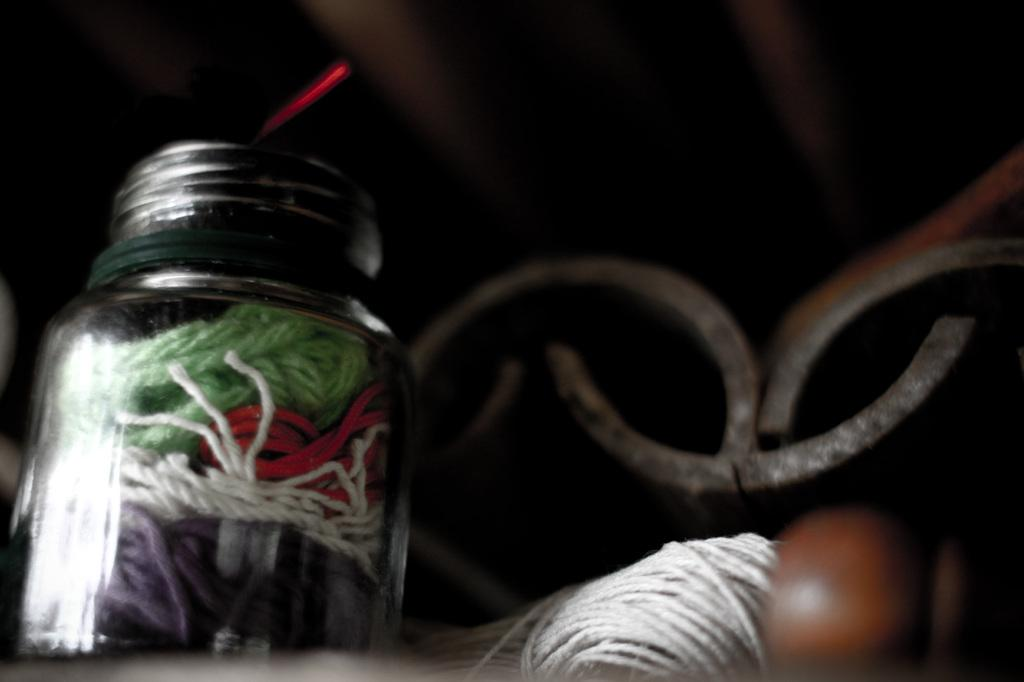What object is visible in the image that is made of glass? There is a glass bottle in the image. What is inside the glass bottle? Colorful threads are inside the bottle. What can be seen on the right side of the image? There is a bundle of white color thread and metal present on the right side of the image. How does the disgust factor in the image affect the overall aesthetic? There is no mention of disgust or any negative emotions in the image, so it cannot be determined how it affects the overall aesthetic. 